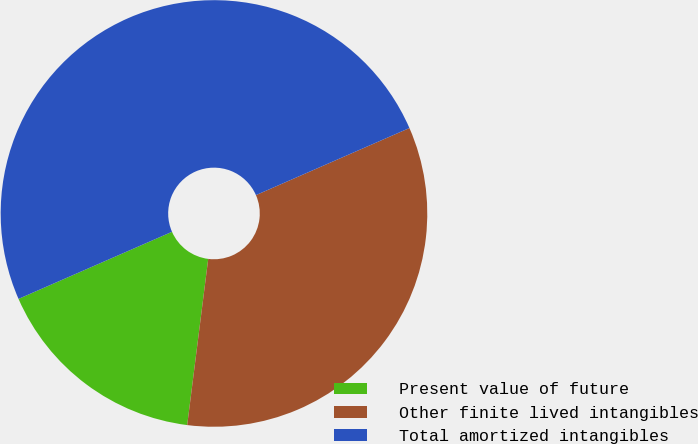Convert chart to OTSL. <chart><loc_0><loc_0><loc_500><loc_500><pie_chart><fcel>Present value of future<fcel>Other finite lived intangibles<fcel>Total amortized intangibles<nl><fcel>16.44%<fcel>33.56%<fcel>50.0%<nl></chart> 